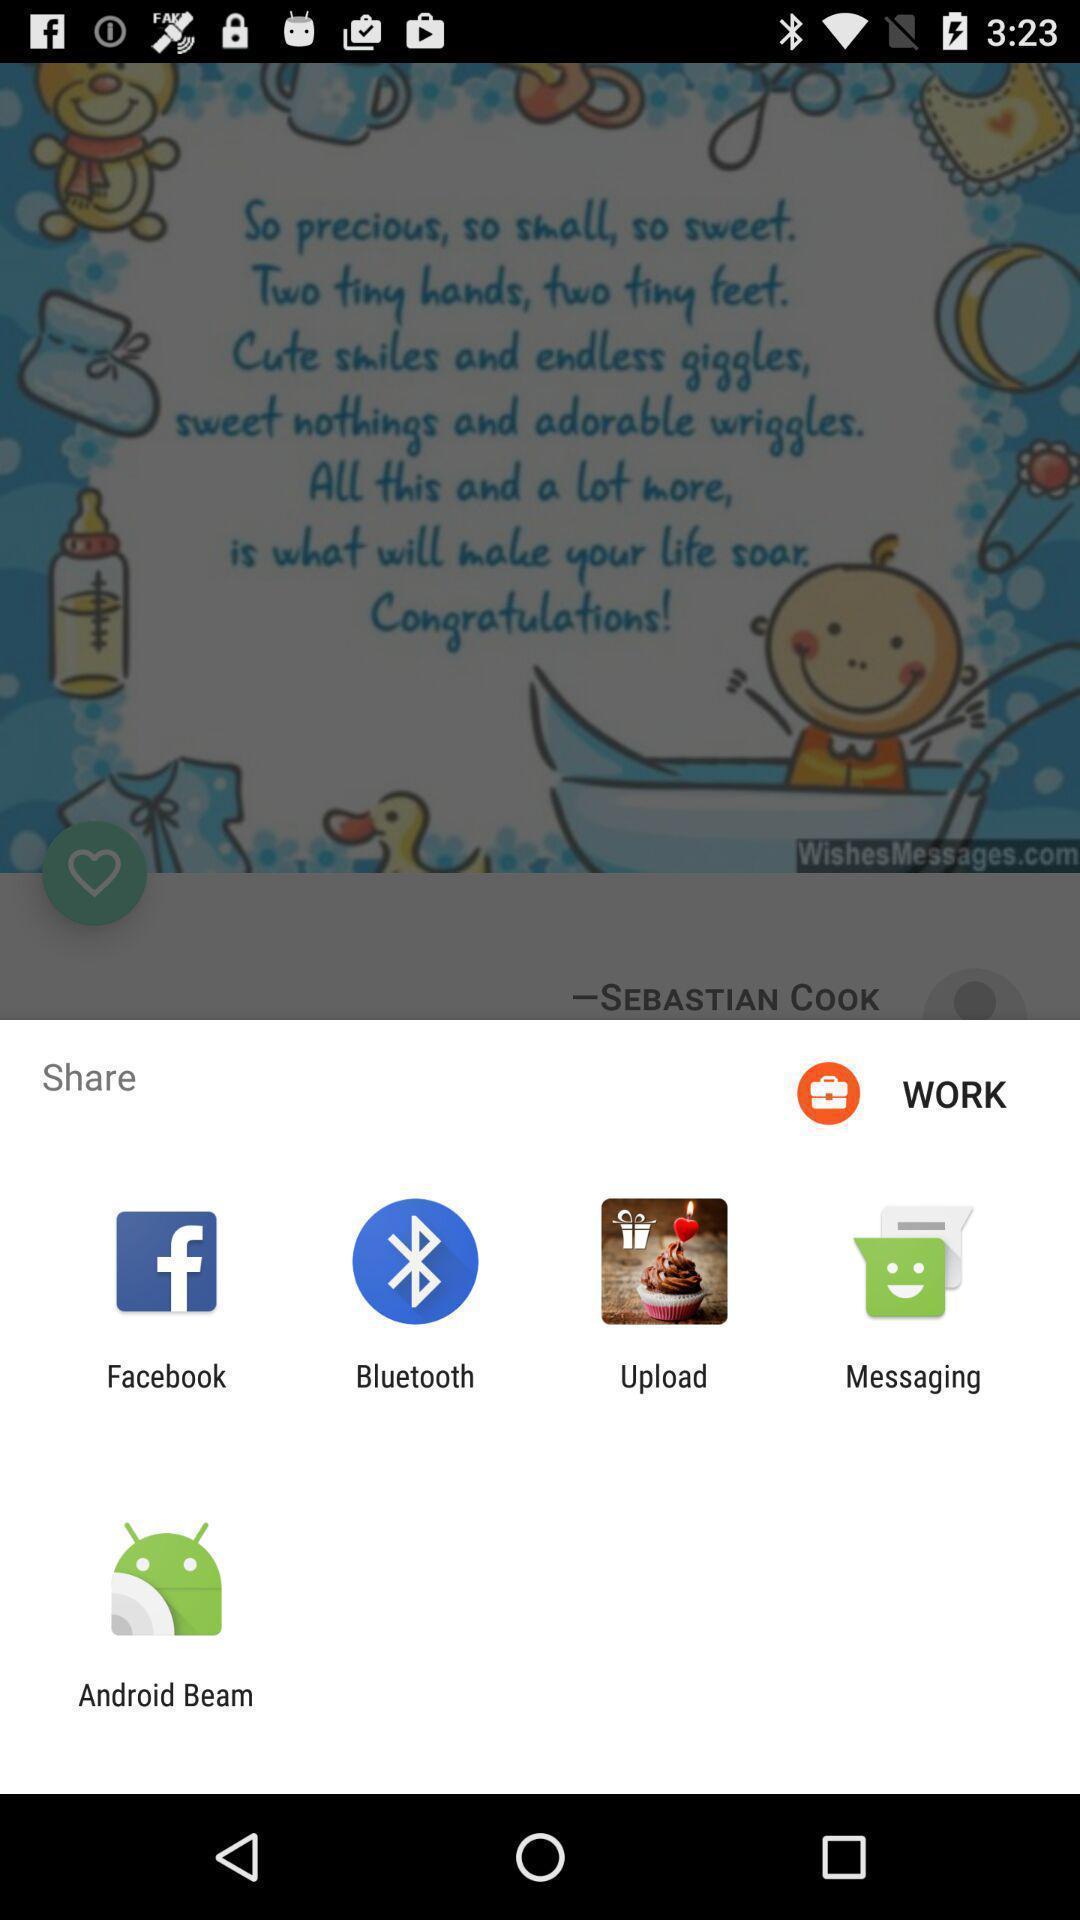Explain the elements present in this screenshot. Pop up showing various apps to share. 